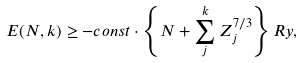Convert formula to latex. <formula><loc_0><loc_0><loc_500><loc_500>E ( N , k ) \geq - c o n s t \cdot \left \{ N + \sum _ { j } ^ { k } Z _ { j } ^ { 7 / 3 } \right \} R y ,</formula> 